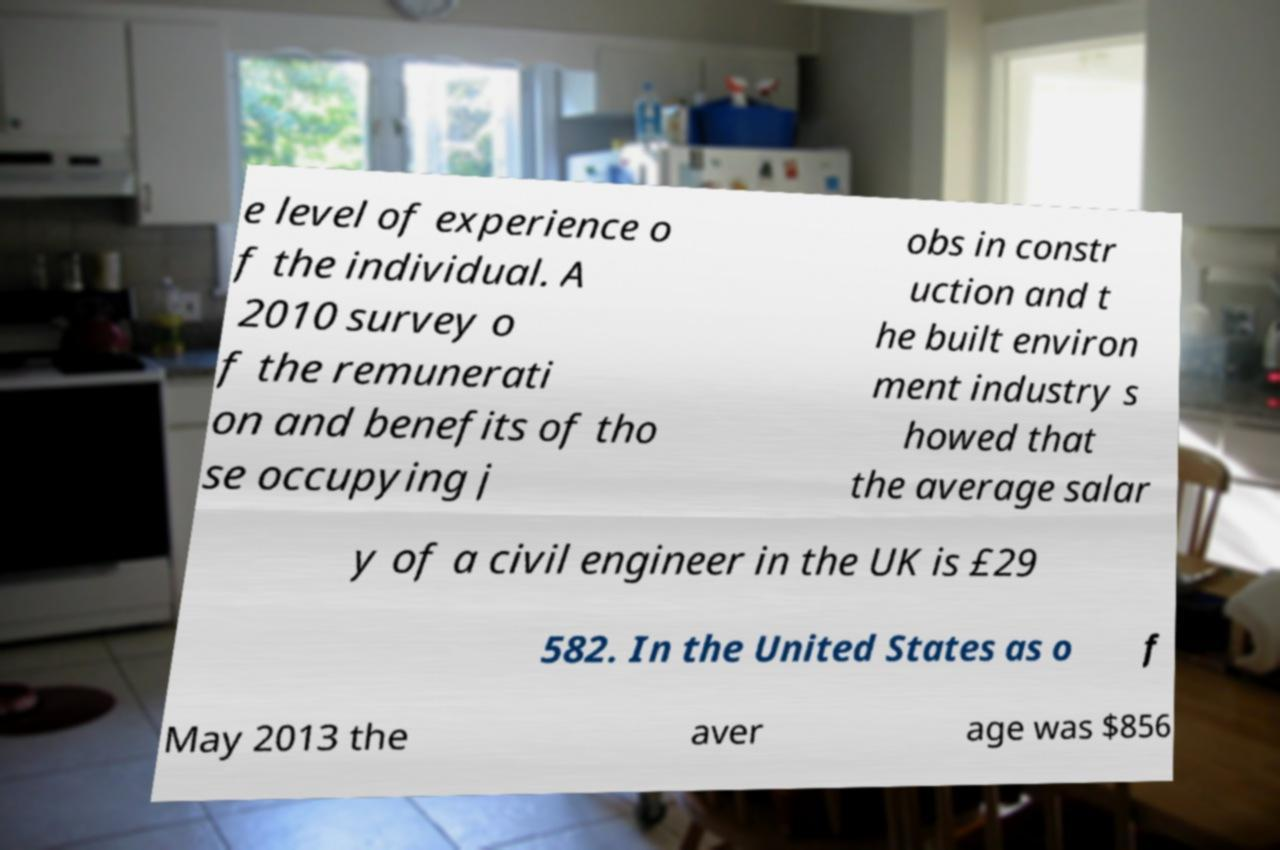Could you extract and type out the text from this image? e level of experience o f the individual. A 2010 survey o f the remunerati on and benefits of tho se occupying j obs in constr uction and t he built environ ment industry s howed that the average salar y of a civil engineer in the UK is £29 582. In the United States as o f May 2013 the aver age was $856 